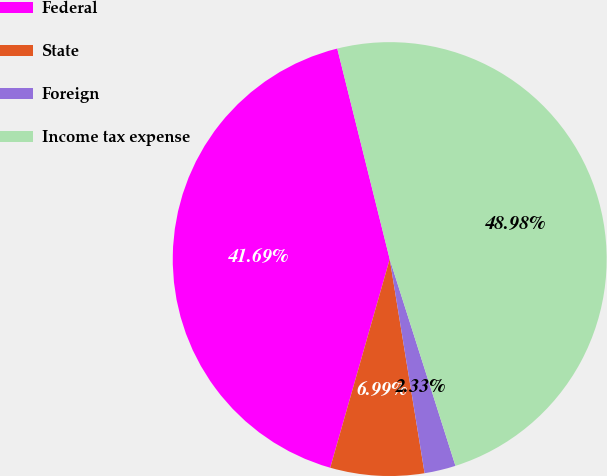Convert chart to OTSL. <chart><loc_0><loc_0><loc_500><loc_500><pie_chart><fcel>Federal<fcel>State<fcel>Foreign<fcel>Income tax expense<nl><fcel>41.69%<fcel>6.99%<fcel>2.33%<fcel>48.98%<nl></chart> 